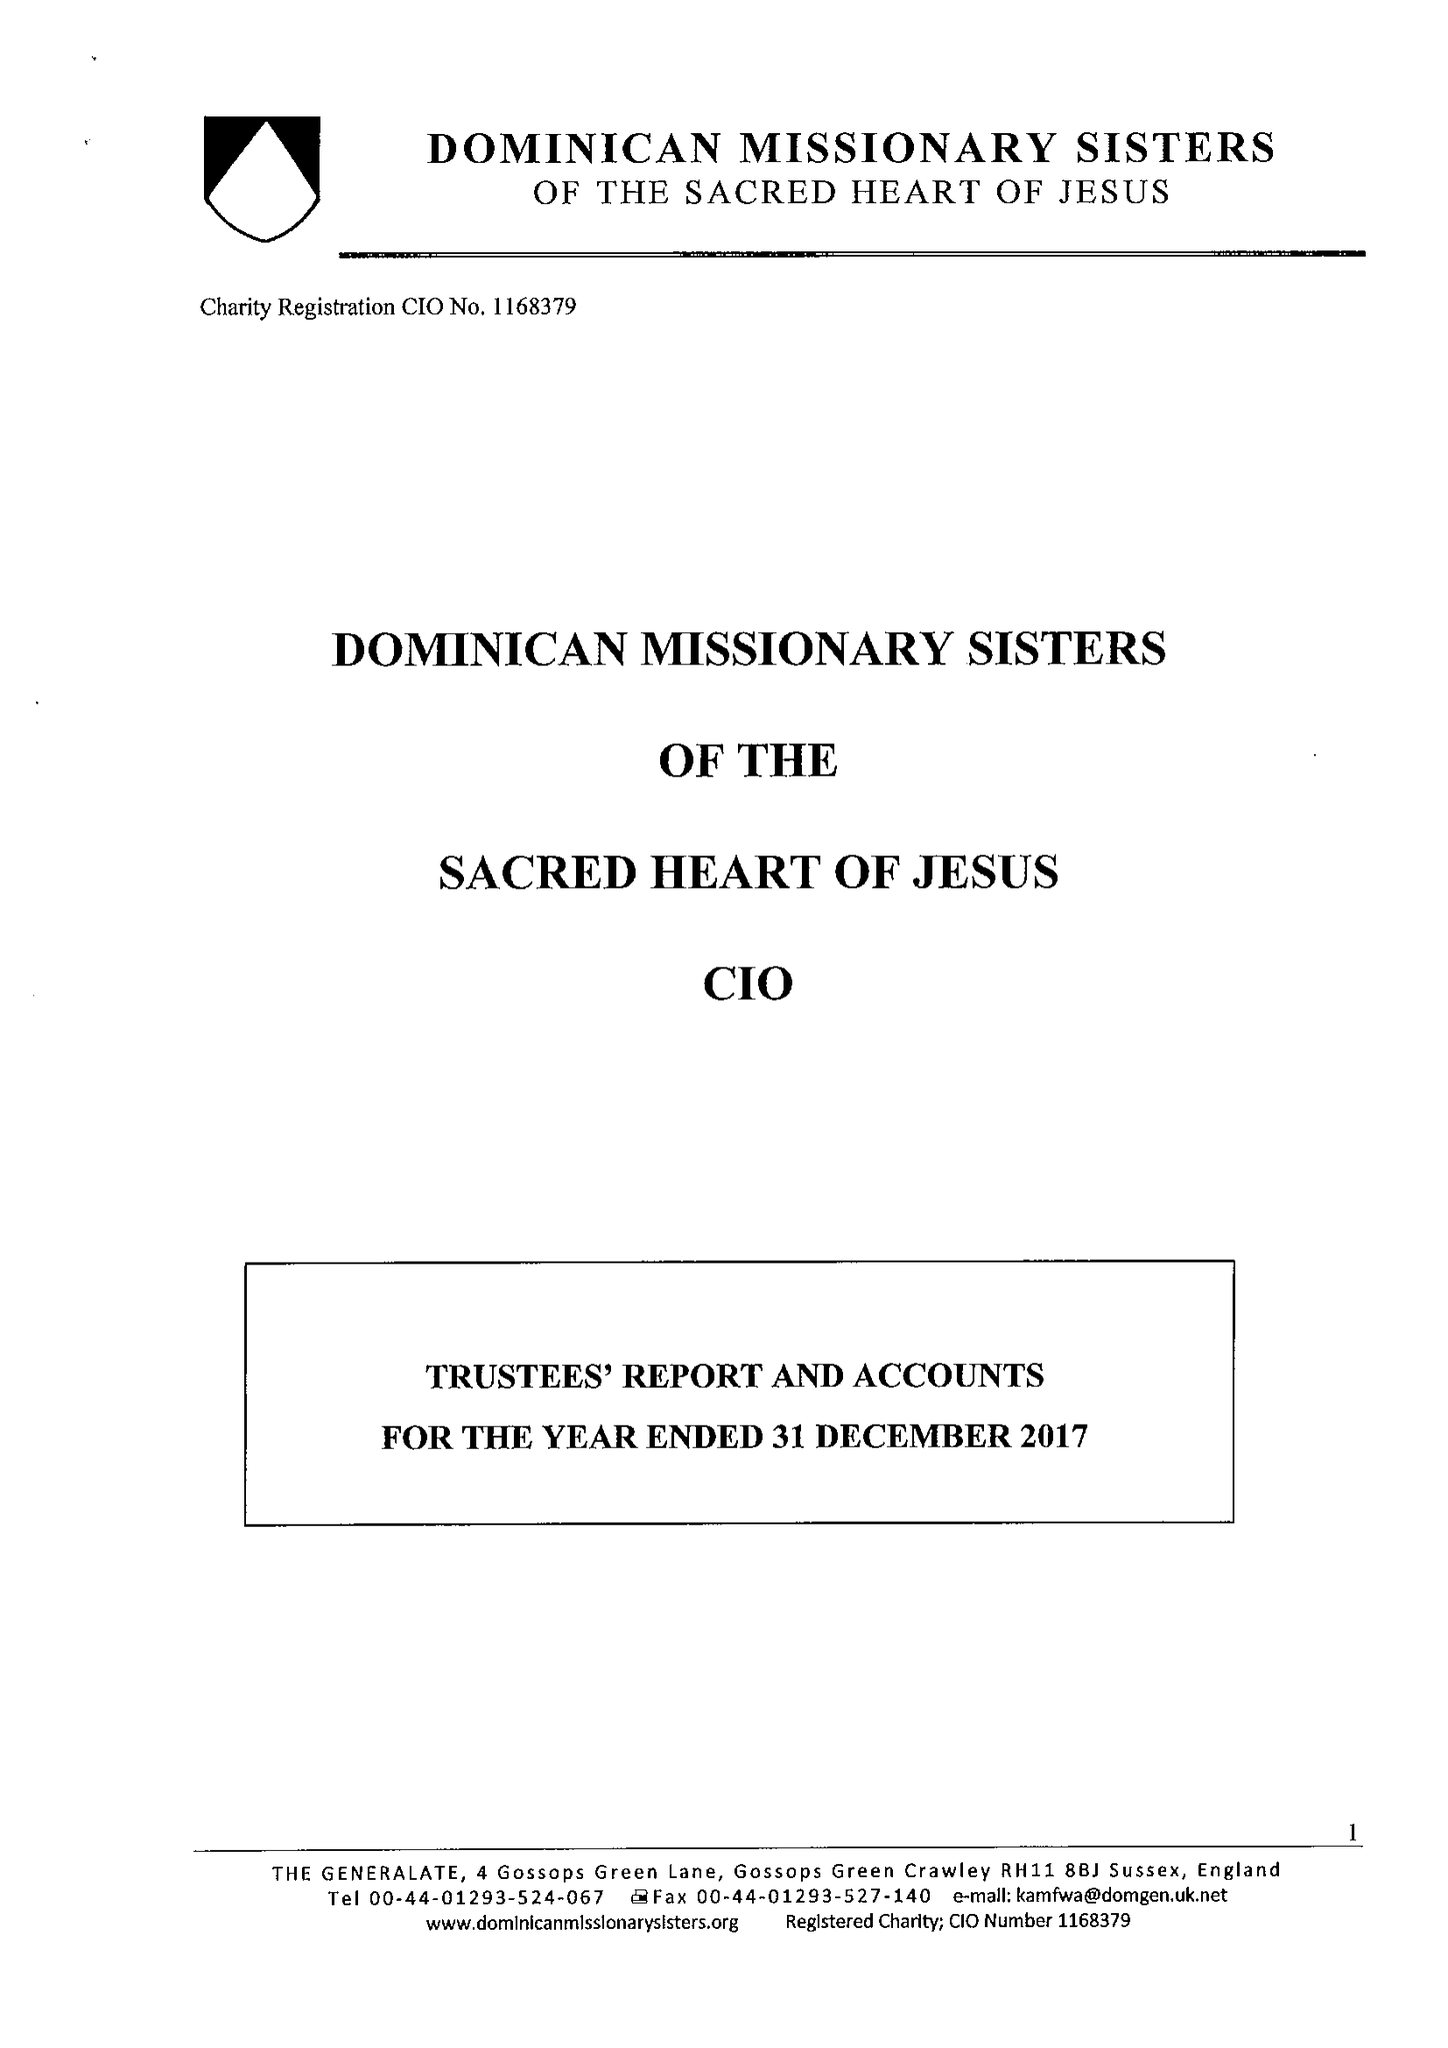What is the value for the charity_number?
Answer the question using a single word or phrase. 1168379 